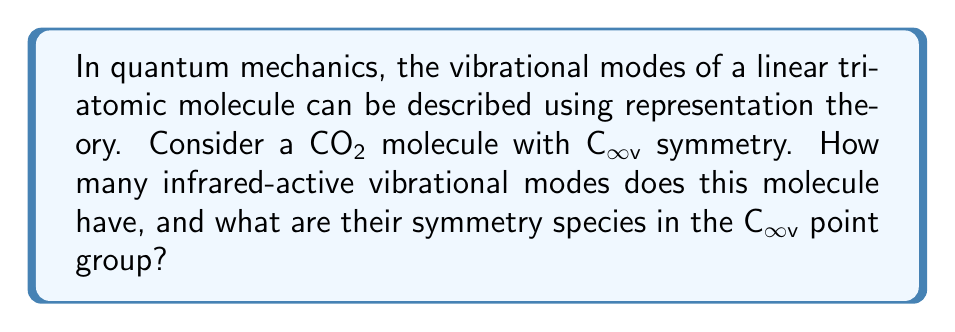Can you answer this question? To solve this problem, we'll use representation theory and group theory concepts:

1. First, we need to determine the number of vibrational modes:
   - For a linear molecule with N atoms, the number of vibrational modes is 3N - 5 = 3(3) - 5 = 4

2. Next, we'll analyze the symmetry of the CO₂ molecule:
   - CO₂ is a linear molecule with C∞v symmetry
   - The irreducible representations for C∞v are A₁, A₂, E₁, E₂, ...

3. We'll consider the symmetry of the possible vibrational modes:
   - Symmetric stretch: A₁g (totally symmetric)
   - Antisymmetric stretch: Σu+
   - Bending modes (degenerate): Πu (two-fold degenerate)

4. Determine which modes are infrared-active:
   - For a mode to be infrared-active, it must involve a change in dipole moment
   - A₁g (symmetric stretch) does not change the dipole moment, so it's not IR-active
   - Σu+ (antisymmetric stretch) changes the dipole moment, so it's IR-active
   - Πu (bending modes) change the dipole moment, so they're IR-active

5. Count the number of IR-active modes:
   - Antisymmetric stretch (Σu+): 1 mode
   - Bending modes (Πu): 2 degenerate modes

Therefore, CO₂ has 3 infrared-active vibrational modes: one Σu+ and two degenerate Πu modes.
Answer: 3 IR-active modes: Σu+ and Πu (doubly degenerate) 